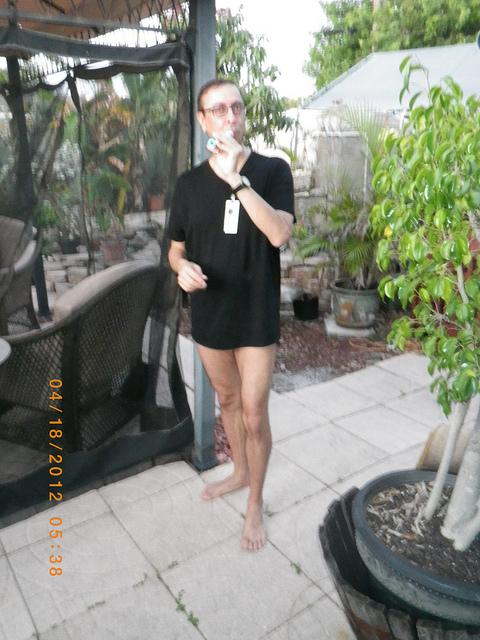Who is likely taking this picture in relation to the person who poses? wife 